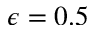Convert formula to latex. <formula><loc_0><loc_0><loc_500><loc_500>\epsilon = 0 . 5</formula> 